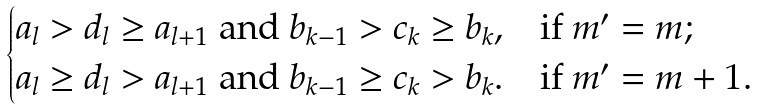Convert formula to latex. <formula><loc_0><loc_0><loc_500><loc_500>\begin{cases} a _ { l } > d _ { l } \geq a _ { l + 1 } \text { and } b _ { k - 1 } > c _ { k } \geq b _ { k } , & \text {if $m^{\prime}=m$} ; \\ a _ { l } \geq d _ { l } > a _ { l + 1 } \text { and } b _ { k - 1 } \geq c _ { k } > b _ { k } . & \text {if $m^{\prime}=m+1$} . \end{cases}</formula> 